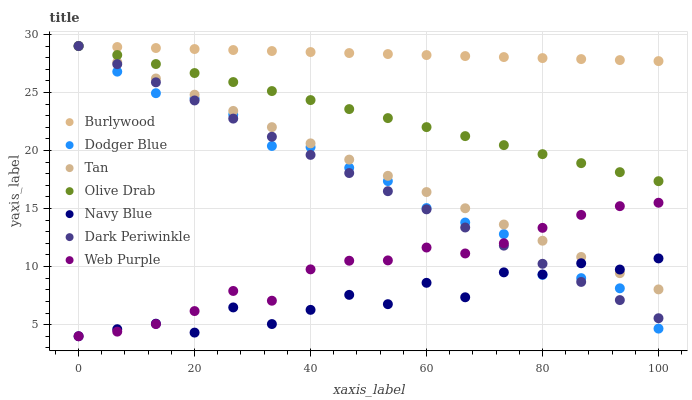Does Navy Blue have the minimum area under the curve?
Answer yes or no. Yes. Does Burlywood have the maximum area under the curve?
Answer yes or no. Yes. Does Web Purple have the minimum area under the curve?
Answer yes or no. No. Does Web Purple have the maximum area under the curve?
Answer yes or no. No. Is Burlywood the smoothest?
Answer yes or no. Yes. Is Navy Blue the roughest?
Answer yes or no. Yes. Is Web Purple the smoothest?
Answer yes or no. No. Is Web Purple the roughest?
Answer yes or no. No. Does Navy Blue have the lowest value?
Answer yes or no. Yes. Does Dodger Blue have the lowest value?
Answer yes or no. No. Does Olive Drab have the highest value?
Answer yes or no. Yes. Does Web Purple have the highest value?
Answer yes or no. No. Is Web Purple less than Burlywood?
Answer yes or no. Yes. Is Burlywood greater than Navy Blue?
Answer yes or no. Yes. Does Burlywood intersect Dodger Blue?
Answer yes or no. Yes. Is Burlywood less than Dodger Blue?
Answer yes or no. No. Is Burlywood greater than Dodger Blue?
Answer yes or no. No. Does Web Purple intersect Burlywood?
Answer yes or no. No. 